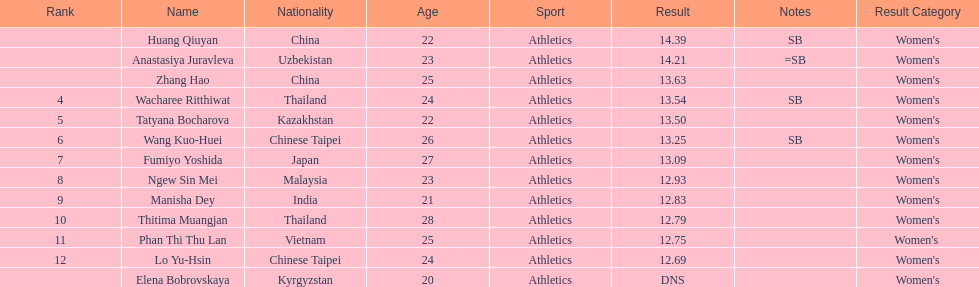What is the number of different nationalities represented by the top 5 athletes? 4. 